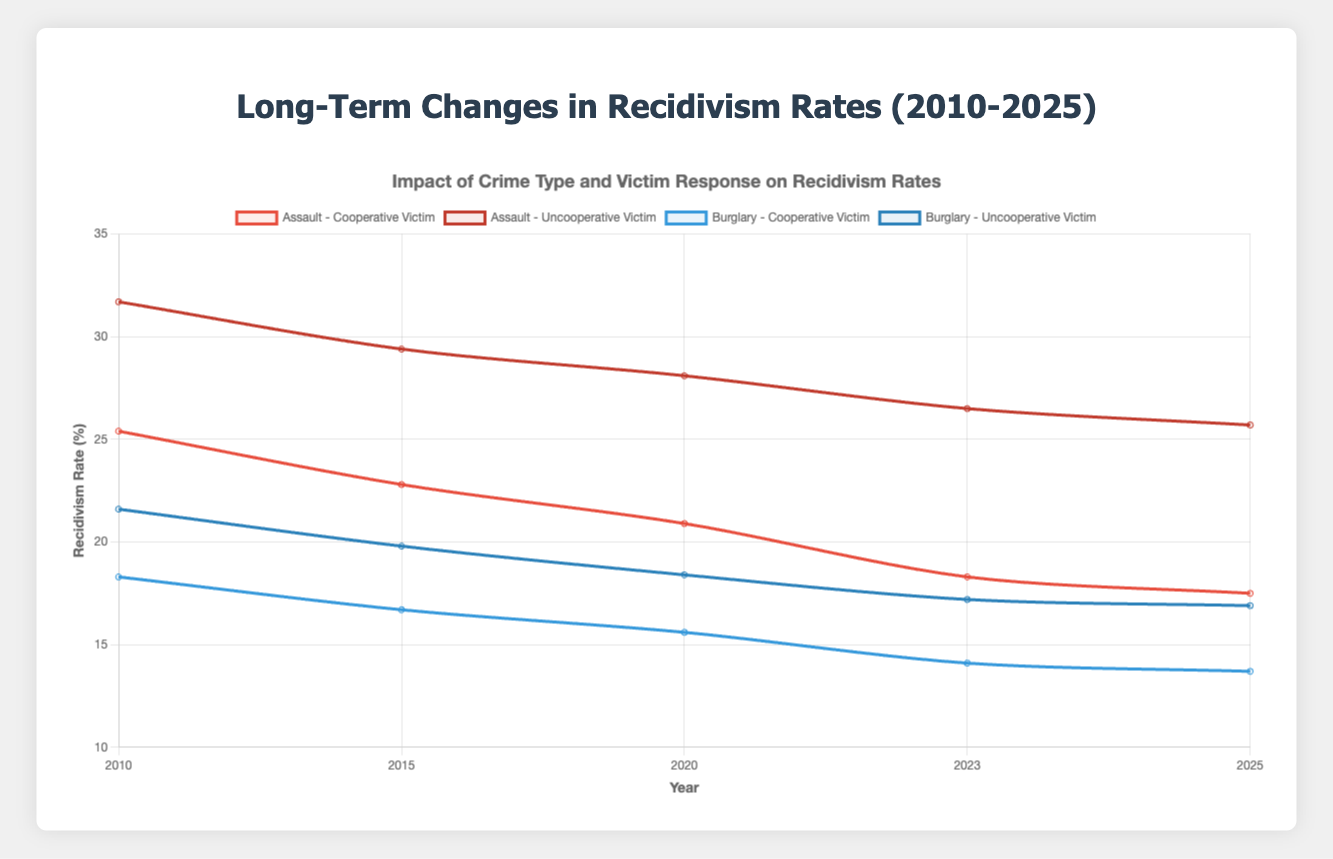What is the general trend in recidivism rates for Assault crimes with cooperative victims from 2010 to 2025? The recidivism rate for Assault crimes with cooperative victims generally decreases from 25.4% in 2010 to 17.5% in 2025. The rate drops steadily across the years, showing a long-term downward trend.
Answer: Decreasing Compare the recidivism rates for Burglary crimes between cooperative and uncooperative victims in 2025. In 2025, the recidivism rate for Burglary crimes with cooperative victims is 13.7%, while for uncooperative victims it is 16.9%. Therefore, the rate is lower for cooperative victims.
Answer: Cooperative: 13.7%, Uncooperative: 16.9% Which crime type and victim response combination shows the highest recidivism rate in 2020? In 2020, the highest recidivism rate is for Assault crimes with uncooperative victims, which has a rate of 28.1%. By examining the plot, it's clear that this data point is the maximum among all combinations.
Answer: Assault with Uncooperative Victims Calculate the average recidivism rate for Burglary crimes with cooperative victims across the years provided. The recidivism rates for Burglary crimes with cooperative victims across the years are: 18.3% (2010), 16.7% (2015), 15.6% (2020), 14.1% (2023), and 13.7% (2025). Summing these up gives 78.4%. Dividing by 5 gives the average: 78.4% / 5 = 15.68%.
Answer: 15.68% How do the recidivism rates for Assault crimes with cooperative victims change from 2020 to 2025? In 2020, the recidivism rate for Assault crimes with cooperative victims is 20.9%. By 2025, it decreases to 17.5%. Hence, the rate drops by 3.4% over this period.
Answer: Decreased by 3.4% Which group shows a more significant decline in recidivism rates from 2010 to 2025: Assault with cooperative victims or Assault with uncooperative victims? For Assault crimes with cooperative victims, the rate decreases from 25.4% in 2010 to 17.5% in 2025, a decline of 7.9%. For uncooperative victims, it goes from 31.7% to 25.7%, a decline of 6%. Hence, cooperative victims show a more significant decline.
Answer: Assault with Cooperative Victims Examine the color coding of the plot. What color is used to represent the recidivism rate data for Burglary crimes with uncooperative victims? The recidivism rate data for Burglary crimes with uncooperative victims is represented by a navy blue color. This can be observed by matching the legend description with the data line color.
Answer: Navy Blue Identify the year where recidivism rates for both Assault crimes with cooperative victims and Burglary crimes with uncooperative victims are most similar. By examining the data points across the years, in 2025, the rates are 17.5% for Assault with cooperative victims and 16.9% for Burglary uncooperative victims, making them relatively similar compared to other years.
Answer: 2025 Which crime type and victim response show the least recidivism rate in 2010? In 2010, the least recidivism rate is observed for Burglary crimes with cooperative victims, which is 18.3%.
Answer: Burglary with Cooperative Victims 